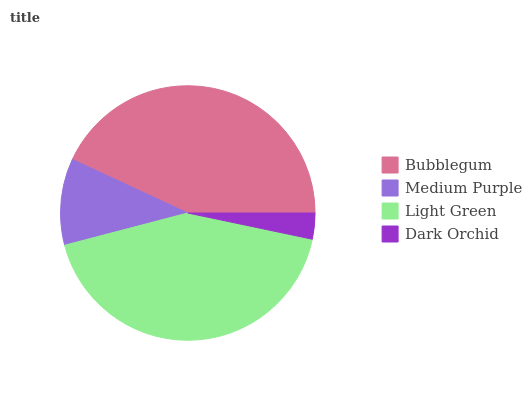Is Dark Orchid the minimum?
Answer yes or no. Yes. Is Bubblegum the maximum?
Answer yes or no. Yes. Is Medium Purple the minimum?
Answer yes or no. No. Is Medium Purple the maximum?
Answer yes or no. No. Is Bubblegum greater than Medium Purple?
Answer yes or no. Yes. Is Medium Purple less than Bubblegum?
Answer yes or no. Yes. Is Medium Purple greater than Bubblegum?
Answer yes or no. No. Is Bubblegum less than Medium Purple?
Answer yes or no. No. Is Light Green the high median?
Answer yes or no. Yes. Is Medium Purple the low median?
Answer yes or no. Yes. Is Bubblegum the high median?
Answer yes or no. No. Is Bubblegum the low median?
Answer yes or no. No. 